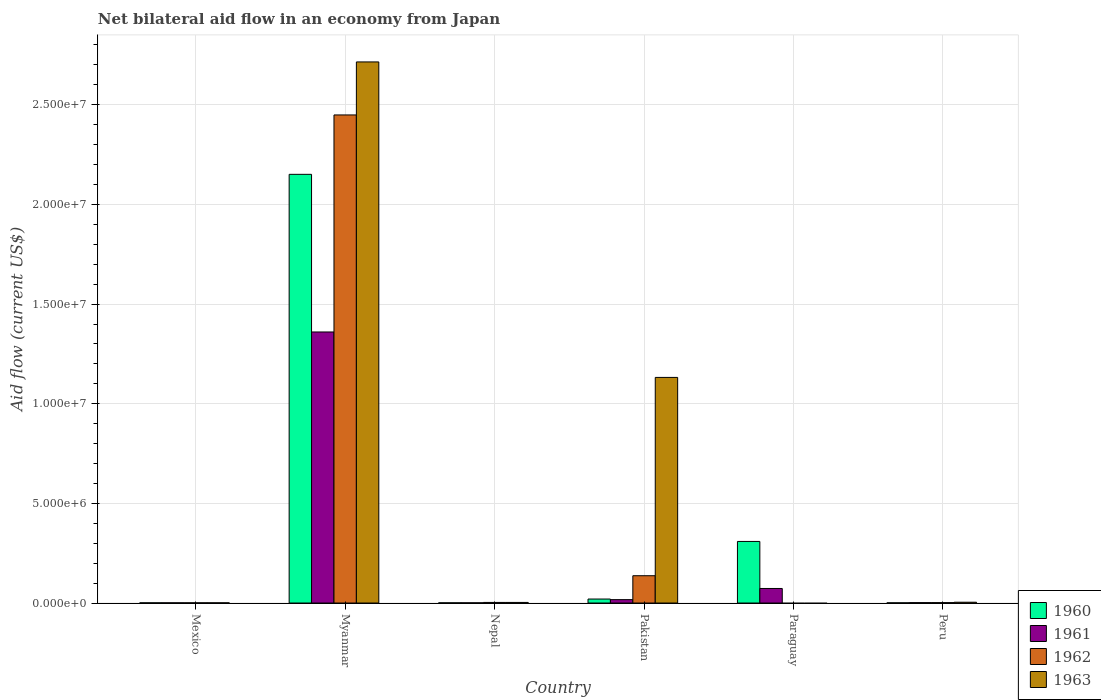How many different coloured bars are there?
Ensure brevity in your answer.  4. How many groups of bars are there?
Make the answer very short. 6. Are the number of bars per tick equal to the number of legend labels?
Make the answer very short. No. Are the number of bars on each tick of the X-axis equal?
Provide a succinct answer. No. What is the label of the 2nd group of bars from the left?
Your answer should be very brief. Myanmar. In how many cases, is the number of bars for a given country not equal to the number of legend labels?
Give a very brief answer. 1. What is the net bilateral aid flow in 1963 in Paraguay?
Your response must be concise. 0. Across all countries, what is the maximum net bilateral aid flow in 1961?
Make the answer very short. 1.36e+07. In which country was the net bilateral aid flow in 1963 maximum?
Keep it short and to the point. Myanmar. What is the total net bilateral aid flow in 1962 in the graph?
Provide a short and direct response. 2.59e+07. What is the difference between the net bilateral aid flow in 1963 in Nepal and that in Pakistan?
Offer a very short reply. -1.13e+07. What is the average net bilateral aid flow in 1961 per country?
Provide a short and direct response. 2.42e+06. What is the difference between the net bilateral aid flow of/in 1961 and net bilateral aid flow of/in 1960 in Paraguay?
Provide a short and direct response. -2.36e+06. In how many countries, is the net bilateral aid flow in 1961 greater than 20000000 US$?
Your answer should be compact. 0. What is the ratio of the net bilateral aid flow in 1962 in Mexico to that in Nepal?
Ensure brevity in your answer.  0.33. Is the net bilateral aid flow in 1962 in Myanmar less than that in Peru?
Ensure brevity in your answer.  No. What is the difference between the highest and the second highest net bilateral aid flow in 1963?
Keep it short and to the point. 2.71e+07. What is the difference between the highest and the lowest net bilateral aid flow in 1960?
Offer a very short reply. 2.15e+07. Is the sum of the net bilateral aid flow in 1962 in Mexico and Pakistan greater than the maximum net bilateral aid flow in 1963 across all countries?
Give a very brief answer. No. Are the values on the major ticks of Y-axis written in scientific E-notation?
Give a very brief answer. Yes. Does the graph contain grids?
Ensure brevity in your answer.  Yes. How many legend labels are there?
Provide a short and direct response. 4. How are the legend labels stacked?
Ensure brevity in your answer.  Vertical. What is the title of the graph?
Provide a short and direct response. Net bilateral aid flow in an economy from Japan. Does "2012" appear as one of the legend labels in the graph?
Your answer should be very brief. No. What is the label or title of the Y-axis?
Make the answer very short. Aid flow (current US$). What is the Aid flow (current US$) in 1962 in Mexico?
Offer a very short reply. 10000. What is the Aid flow (current US$) of 1963 in Mexico?
Give a very brief answer. 10000. What is the Aid flow (current US$) of 1960 in Myanmar?
Provide a short and direct response. 2.15e+07. What is the Aid flow (current US$) of 1961 in Myanmar?
Give a very brief answer. 1.36e+07. What is the Aid flow (current US$) in 1962 in Myanmar?
Offer a very short reply. 2.45e+07. What is the Aid flow (current US$) in 1963 in Myanmar?
Keep it short and to the point. 2.72e+07. What is the Aid flow (current US$) of 1961 in Nepal?
Keep it short and to the point. 10000. What is the Aid flow (current US$) of 1962 in Nepal?
Offer a very short reply. 3.00e+04. What is the Aid flow (current US$) in 1960 in Pakistan?
Your answer should be very brief. 2.00e+05. What is the Aid flow (current US$) in 1962 in Pakistan?
Provide a succinct answer. 1.37e+06. What is the Aid flow (current US$) of 1963 in Pakistan?
Your answer should be compact. 1.13e+07. What is the Aid flow (current US$) in 1960 in Paraguay?
Give a very brief answer. 3.09e+06. What is the Aid flow (current US$) in 1961 in Paraguay?
Offer a terse response. 7.30e+05. What is the Aid flow (current US$) of 1962 in Paraguay?
Ensure brevity in your answer.  0. What is the Aid flow (current US$) of 1961 in Peru?
Provide a succinct answer. 2.00e+04. Across all countries, what is the maximum Aid flow (current US$) in 1960?
Your answer should be very brief. 2.15e+07. Across all countries, what is the maximum Aid flow (current US$) of 1961?
Provide a succinct answer. 1.36e+07. Across all countries, what is the maximum Aid flow (current US$) in 1962?
Make the answer very short. 2.45e+07. Across all countries, what is the maximum Aid flow (current US$) of 1963?
Make the answer very short. 2.72e+07. Across all countries, what is the minimum Aid flow (current US$) in 1962?
Keep it short and to the point. 0. Across all countries, what is the minimum Aid flow (current US$) in 1963?
Your response must be concise. 0. What is the total Aid flow (current US$) of 1960 in the graph?
Provide a succinct answer. 2.48e+07. What is the total Aid flow (current US$) of 1961 in the graph?
Provide a short and direct response. 1.45e+07. What is the total Aid flow (current US$) in 1962 in the graph?
Ensure brevity in your answer.  2.59e+07. What is the total Aid flow (current US$) of 1963 in the graph?
Provide a succinct answer. 3.86e+07. What is the difference between the Aid flow (current US$) in 1960 in Mexico and that in Myanmar?
Offer a terse response. -2.15e+07. What is the difference between the Aid flow (current US$) of 1961 in Mexico and that in Myanmar?
Provide a short and direct response. -1.36e+07. What is the difference between the Aid flow (current US$) of 1962 in Mexico and that in Myanmar?
Your response must be concise. -2.45e+07. What is the difference between the Aid flow (current US$) of 1963 in Mexico and that in Myanmar?
Your answer should be compact. -2.71e+07. What is the difference between the Aid flow (current US$) in 1960 in Mexico and that in Nepal?
Give a very brief answer. 0. What is the difference between the Aid flow (current US$) in 1962 in Mexico and that in Nepal?
Your response must be concise. -2.00e+04. What is the difference between the Aid flow (current US$) in 1963 in Mexico and that in Nepal?
Provide a succinct answer. -2.00e+04. What is the difference between the Aid flow (current US$) of 1962 in Mexico and that in Pakistan?
Give a very brief answer. -1.36e+06. What is the difference between the Aid flow (current US$) of 1963 in Mexico and that in Pakistan?
Offer a terse response. -1.13e+07. What is the difference between the Aid flow (current US$) in 1960 in Mexico and that in Paraguay?
Keep it short and to the point. -3.08e+06. What is the difference between the Aid flow (current US$) of 1961 in Mexico and that in Paraguay?
Your answer should be compact. -7.20e+05. What is the difference between the Aid flow (current US$) of 1960 in Mexico and that in Peru?
Your answer should be very brief. 0. What is the difference between the Aid flow (current US$) of 1961 in Mexico and that in Peru?
Make the answer very short. -10000. What is the difference between the Aid flow (current US$) of 1962 in Mexico and that in Peru?
Keep it short and to the point. -10000. What is the difference between the Aid flow (current US$) in 1963 in Mexico and that in Peru?
Give a very brief answer. -3.00e+04. What is the difference between the Aid flow (current US$) of 1960 in Myanmar and that in Nepal?
Give a very brief answer. 2.15e+07. What is the difference between the Aid flow (current US$) of 1961 in Myanmar and that in Nepal?
Your answer should be compact. 1.36e+07. What is the difference between the Aid flow (current US$) of 1962 in Myanmar and that in Nepal?
Your response must be concise. 2.45e+07. What is the difference between the Aid flow (current US$) of 1963 in Myanmar and that in Nepal?
Keep it short and to the point. 2.71e+07. What is the difference between the Aid flow (current US$) in 1960 in Myanmar and that in Pakistan?
Provide a short and direct response. 2.13e+07. What is the difference between the Aid flow (current US$) in 1961 in Myanmar and that in Pakistan?
Your answer should be very brief. 1.34e+07. What is the difference between the Aid flow (current US$) in 1962 in Myanmar and that in Pakistan?
Make the answer very short. 2.31e+07. What is the difference between the Aid flow (current US$) of 1963 in Myanmar and that in Pakistan?
Provide a short and direct response. 1.58e+07. What is the difference between the Aid flow (current US$) in 1960 in Myanmar and that in Paraguay?
Give a very brief answer. 1.84e+07. What is the difference between the Aid flow (current US$) in 1961 in Myanmar and that in Paraguay?
Give a very brief answer. 1.29e+07. What is the difference between the Aid flow (current US$) in 1960 in Myanmar and that in Peru?
Offer a very short reply. 2.15e+07. What is the difference between the Aid flow (current US$) in 1961 in Myanmar and that in Peru?
Keep it short and to the point. 1.36e+07. What is the difference between the Aid flow (current US$) of 1962 in Myanmar and that in Peru?
Give a very brief answer. 2.45e+07. What is the difference between the Aid flow (current US$) of 1963 in Myanmar and that in Peru?
Provide a short and direct response. 2.71e+07. What is the difference between the Aid flow (current US$) in 1961 in Nepal and that in Pakistan?
Offer a very short reply. -1.60e+05. What is the difference between the Aid flow (current US$) in 1962 in Nepal and that in Pakistan?
Provide a succinct answer. -1.34e+06. What is the difference between the Aid flow (current US$) of 1963 in Nepal and that in Pakistan?
Keep it short and to the point. -1.13e+07. What is the difference between the Aid flow (current US$) in 1960 in Nepal and that in Paraguay?
Your answer should be very brief. -3.08e+06. What is the difference between the Aid flow (current US$) of 1961 in Nepal and that in Paraguay?
Provide a succinct answer. -7.20e+05. What is the difference between the Aid flow (current US$) of 1962 in Nepal and that in Peru?
Give a very brief answer. 10000. What is the difference between the Aid flow (current US$) of 1960 in Pakistan and that in Paraguay?
Give a very brief answer. -2.89e+06. What is the difference between the Aid flow (current US$) in 1961 in Pakistan and that in Paraguay?
Ensure brevity in your answer.  -5.60e+05. What is the difference between the Aid flow (current US$) in 1960 in Pakistan and that in Peru?
Offer a terse response. 1.90e+05. What is the difference between the Aid flow (current US$) of 1962 in Pakistan and that in Peru?
Provide a short and direct response. 1.35e+06. What is the difference between the Aid flow (current US$) in 1963 in Pakistan and that in Peru?
Make the answer very short. 1.13e+07. What is the difference between the Aid flow (current US$) in 1960 in Paraguay and that in Peru?
Your response must be concise. 3.08e+06. What is the difference between the Aid flow (current US$) in 1961 in Paraguay and that in Peru?
Your answer should be very brief. 7.10e+05. What is the difference between the Aid flow (current US$) of 1960 in Mexico and the Aid flow (current US$) of 1961 in Myanmar?
Offer a terse response. -1.36e+07. What is the difference between the Aid flow (current US$) of 1960 in Mexico and the Aid flow (current US$) of 1962 in Myanmar?
Ensure brevity in your answer.  -2.45e+07. What is the difference between the Aid flow (current US$) of 1960 in Mexico and the Aid flow (current US$) of 1963 in Myanmar?
Offer a very short reply. -2.71e+07. What is the difference between the Aid flow (current US$) in 1961 in Mexico and the Aid flow (current US$) in 1962 in Myanmar?
Provide a short and direct response. -2.45e+07. What is the difference between the Aid flow (current US$) in 1961 in Mexico and the Aid flow (current US$) in 1963 in Myanmar?
Keep it short and to the point. -2.71e+07. What is the difference between the Aid flow (current US$) in 1962 in Mexico and the Aid flow (current US$) in 1963 in Myanmar?
Give a very brief answer. -2.71e+07. What is the difference between the Aid flow (current US$) in 1960 in Mexico and the Aid flow (current US$) in 1962 in Nepal?
Make the answer very short. -2.00e+04. What is the difference between the Aid flow (current US$) of 1962 in Mexico and the Aid flow (current US$) of 1963 in Nepal?
Keep it short and to the point. -2.00e+04. What is the difference between the Aid flow (current US$) of 1960 in Mexico and the Aid flow (current US$) of 1961 in Pakistan?
Provide a succinct answer. -1.60e+05. What is the difference between the Aid flow (current US$) in 1960 in Mexico and the Aid flow (current US$) in 1962 in Pakistan?
Give a very brief answer. -1.36e+06. What is the difference between the Aid flow (current US$) of 1960 in Mexico and the Aid flow (current US$) of 1963 in Pakistan?
Offer a very short reply. -1.13e+07. What is the difference between the Aid flow (current US$) in 1961 in Mexico and the Aid flow (current US$) in 1962 in Pakistan?
Offer a terse response. -1.36e+06. What is the difference between the Aid flow (current US$) of 1961 in Mexico and the Aid flow (current US$) of 1963 in Pakistan?
Your answer should be compact. -1.13e+07. What is the difference between the Aid flow (current US$) of 1962 in Mexico and the Aid flow (current US$) of 1963 in Pakistan?
Your answer should be very brief. -1.13e+07. What is the difference between the Aid flow (current US$) of 1960 in Mexico and the Aid flow (current US$) of 1961 in Paraguay?
Offer a very short reply. -7.20e+05. What is the difference between the Aid flow (current US$) of 1960 in Mexico and the Aid flow (current US$) of 1961 in Peru?
Provide a short and direct response. -10000. What is the difference between the Aid flow (current US$) of 1961 in Mexico and the Aid flow (current US$) of 1963 in Peru?
Your answer should be very brief. -3.00e+04. What is the difference between the Aid flow (current US$) in 1960 in Myanmar and the Aid flow (current US$) in 1961 in Nepal?
Your response must be concise. 2.15e+07. What is the difference between the Aid flow (current US$) in 1960 in Myanmar and the Aid flow (current US$) in 1962 in Nepal?
Your answer should be very brief. 2.15e+07. What is the difference between the Aid flow (current US$) of 1960 in Myanmar and the Aid flow (current US$) of 1963 in Nepal?
Provide a succinct answer. 2.15e+07. What is the difference between the Aid flow (current US$) of 1961 in Myanmar and the Aid flow (current US$) of 1962 in Nepal?
Make the answer very short. 1.36e+07. What is the difference between the Aid flow (current US$) of 1961 in Myanmar and the Aid flow (current US$) of 1963 in Nepal?
Offer a very short reply. 1.36e+07. What is the difference between the Aid flow (current US$) of 1962 in Myanmar and the Aid flow (current US$) of 1963 in Nepal?
Give a very brief answer. 2.45e+07. What is the difference between the Aid flow (current US$) of 1960 in Myanmar and the Aid flow (current US$) of 1961 in Pakistan?
Your answer should be very brief. 2.13e+07. What is the difference between the Aid flow (current US$) of 1960 in Myanmar and the Aid flow (current US$) of 1962 in Pakistan?
Provide a succinct answer. 2.01e+07. What is the difference between the Aid flow (current US$) of 1960 in Myanmar and the Aid flow (current US$) of 1963 in Pakistan?
Keep it short and to the point. 1.02e+07. What is the difference between the Aid flow (current US$) of 1961 in Myanmar and the Aid flow (current US$) of 1962 in Pakistan?
Give a very brief answer. 1.22e+07. What is the difference between the Aid flow (current US$) of 1961 in Myanmar and the Aid flow (current US$) of 1963 in Pakistan?
Make the answer very short. 2.28e+06. What is the difference between the Aid flow (current US$) of 1962 in Myanmar and the Aid flow (current US$) of 1963 in Pakistan?
Your answer should be very brief. 1.32e+07. What is the difference between the Aid flow (current US$) of 1960 in Myanmar and the Aid flow (current US$) of 1961 in Paraguay?
Offer a very short reply. 2.08e+07. What is the difference between the Aid flow (current US$) in 1960 in Myanmar and the Aid flow (current US$) in 1961 in Peru?
Offer a terse response. 2.15e+07. What is the difference between the Aid flow (current US$) of 1960 in Myanmar and the Aid flow (current US$) of 1962 in Peru?
Offer a terse response. 2.15e+07. What is the difference between the Aid flow (current US$) of 1960 in Myanmar and the Aid flow (current US$) of 1963 in Peru?
Provide a short and direct response. 2.15e+07. What is the difference between the Aid flow (current US$) of 1961 in Myanmar and the Aid flow (current US$) of 1962 in Peru?
Offer a terse response. 1.36e+07. What is the difference between the Aid flow (current US$) of 1961 in Myanmar and the Aid flow (current US$) of 1963 in Peru?
Offer a terse response. 1.36e+07. What is the difference between the Aid flow (current US$) in 1962 in Myanmar and the Aid flow (current US$) in 1963 in Peru?
Your answer should be very brief. 2.44e+07. What is the difference between the Aid flow (current US$) of 1960 in Nepal and the Aid flow (current US$) of 1962 in Pakistan?
Make the answer very short. -1.36e+06. What is the difference between the Aid flow (current US$) in 1960 in Nepal and the Aid flow (current US$) in 1963 in Pakistan?
Provide a short and direct response. -1.13e+07. What is the difference between the Aid flow (current US$) of 1961 in Nepal and the Aid flow (current US$) of 1962 in Pakistan?
Your answer should be very brief. -1.36e+06. What is the difference between the Aid flow (current US$) of 1961 in Nepal and the Aid flow (current US$) of 1963 in Pakistan?
Give a very brief answer. -1.13e+07. What is the difference between the Aid flow (current US$) in 1962 in Nepal and the Aid flow (current US$) in 1963 in Pakistan?
Offer a terse response. -1.13e+07. What is the difference between the Aid flow (current US$) of 1960 in Nepal and the Aid flow (current US$) of 1961 in Paraguay?
Your answer should be very brief. -7.20e+05. What is the difference between the Aid flow (current US$) of 1960 in Nepal and the Aid flow (current US$) of 1961 in Peru?
Provide a short and direct response. -10000. What is the difference between the Aid flow (current US$) in 1960 in Nepal and the Aid flow (current US$) in 1963 in Peru?
Your response must be concise. -3.00e+04. What is the difference between the Aid flow (current US$) of 1961 in Nepal and the Aid flow (current US$) of 1962 in Peru?
Give a very brief answer. -10000. What is the difference between the Aid flow (current US$) in 1961 in Nepal and the Aid flow (current US$) in 1963 in Peru?
Provide a short and direct response. -3.00e+04. What is the difference between the Aid flow (current US$) of 1960 in Pakistan and the Aid flow (current US$) of 1961 in Paraguay?
Provide a succinct answer. -5.30e+05. What is the difference between the Aid flow (current US$) of 1960 in Pakistan and the Aid flow (current US$) of 1962 in Peru?
Your response must be concise. 1.80e+05. What is the difference between the Aid flow (current US$) of 1961 in Pakistan and the Aid flow (current US$) of 1962 in Peru?
Your answer should be very brief. 1.50e+05. What is the difference between the Aid flow (current US$) in 1962 in Pakistan and the Aid flow (current US$) in 1963 in Peru?
Make the answer very short. 1.33e+06. What is the difference between the Aid flow (current US$) in 1960 in Paraguay and the Aid flow (current US$) in 1961 in Peru?
Your answer should be very brief. 3.07e+06. What is the difference between the Aid flow (current US$) of 1960 in Paraguay and the Aid flow (current US$) of 1962 in Peru?
Give a very brief answer. 3.07e+06. What is the difference between the Aid flow (current US$) in 1960 in Paraguay and the Aid flow (current US$) in 1963 in Peru?
Your answer should be compact. 3.05e+06. What is the difference between the Aid flow (current US$) in 1961 in Paraguay and the Aid flow (current US$) in 1962 in Peru?
Your response must be concise. 7.10e+05. What is the difference between the Aid flow (current US$) in 1961 in Paraguay and the Aid flow (current US$) in 1963 in Peru?
Provide a short and direct response. 6.90e+05. What is the average Aid flow (current US$) of 1960 per country?
Your answer should be very brief. 4.14e+06. What is the average Aid flow (current US$) of 1961 per country?
Offer a very short reply. 2.42e+06. What is the average Aid flow (current US$) of 1962 per country?
Keep it short and to the point. 4.32e+06. What is the average Aid flow (current US$) in 1963 per country?
Ensure brevity in your answer.  6.42e+06. What is the difference between the Aid flow (current US$) in 1960 and Aid flow (current US$) in 1961 in Mexico?
Your response must be concise. 0. What is the difference between the Aid flow (current US$) of 1960 and Aid flow (current US$) of 1962 in Mexico?
Give a very brief answer. 0. What is the difference between the Aid flow (current US$) in 1962 and Aid flow (current US$) in 1963 in Mexico?
Your answer should be compact. 0. What is the difference between the Aid flow (current US$) in 1960 and Aid flow (current US$) in 1961 in Myanmar?
Offer a terse response. 7.91e+06. What is the difference between the Aid flow (current US$) of 1960 and Aid flow (current US$) of 1962 in Myanmar?
Provide a succinct answer. -2.98e+06. What is the difference between the Aid flow (current US$) in 1960 and Aid flow (current US$) in 1963 in Myanmar?
Keep it short and to the point. -5.64e+06. What is the difference between the Aid flow (current US$) in 1961 and Aid flow (current US$) in 1962 in Myanmar?
Offer a terse response. -1.09e+07. What is the difference between the Aid flow (current US$) in 1961 and Aid flow (current US$) in 1963 in Myanmar?
Your answer should be compact. -1.36e+07. What is the difference between the Aid flow (current US$) of 1962 and Aid flow (current US$) of 1963 in Myanmar?
Offer a very short reply. -2.66e+06. What is the difference between the Aid flow (current US$) of 1961 and Aid flow (current US$) of 1963 in Nepal?
Provide a short and direct response. -2.00e+04. What is the difference between the Aid flow (current US$) in 1962 and Aid flow (current US$) in 1963 in Nepal?
Your response must be concise. 0. What is the difference between the Aid flow (current US$) in 1960 and Aid flow (current US$) in 1962 in Pakistan?
Give a very brief answer. -1.17e+06. What is the difference between the Aid flow (current US$) in 1960 and Aid flow (current US$) in 1963 in Pakistan?
Provide a succinct answer. -1.11e+07. What is the difference between the Aid flow (current US$) of 1961 and Aid flow (current US$) of 1962 in Pakistan?
Offer a terse response. -1.20e+06. What is the difference between the Aid flow (current US$) of 1961 and Aid flow (current US$) of 1963 in Pakistan?
Keep it short and to the point. -1.12e+07. What is the difference between the Aid flow (current US$) of 1962 and Aid flow (current US$) of 1963 in Pakistan?
Your answer should be very brief. -9.95e+06. What is the difference between the Aid flow (current US$) in 1960 and Aid flow (current US$) in 1961 in Paraguay?
Your answer should be very brief. 2.36e+06. What is the difference between the Aid flow (current US$) of 1961 and Aid flow (current US$) of 1963 in Peru?
Offer a terse response. -2.00e+04. What is the ratio of the Aid flow (current US$) in 1960 in Mexico to that in Myanmar?
Provide a short and direct response. 0. What is the ratio of the Aid flow (current US$) in 1961 in Mexico to that in Myanmar?
Give a very brief answer. 0. What is the ratio of the Aid flow (current US$) of 1963 in Mexico to that in Myanmar?
Offer a terse response. 0. What is the ratio of the Aid flow (current US$) of 1961 in Mexico to that in Nepal?
Your answer should be compact. 1. What is the ratio of the Aid flow (current US$) in 1960 in Mexico to that in Pakistan?
Provide a short and direct response. 0.05. What is the ratio of the Aid flow (current US$) of 1961 in Mexico to that in Pakistan?
Give a very brief answer. 0.06. What is the ratio of the Aid flow (current US$) in 1962 in Mexico to that in Pakistan?
Your answer should be very brief. 0.01. What is the ratio of the Aid flow (current US$) in 1963 in Mexico to that in Pakistan?
Keep it short and to the point. 0. What is the ratio of the Aid flow (current US$) in 1960 in Mexico to that in Paraguay?
Make the answer very short. 0. What is the ratio of the Aid flow (current US$) of 1961 in Mexico to that in Paraguay?
Offer a very short reply. 0.01. What is the ratio of the Aid flow (current US$) in 1962 in Mexico to that in Peru?
Give a very brief answer. 0.5. What is the ratio of the Aid flow (current US$) of 1960 in Myanmar to that in Nepal?
Give a very brief answer. 2151. What is the ratio of the Aid flow (current US$) of 1961 in Myanmar to that in Nepal?
Keep it short and to the point. 1360. What is the ratio of the Aid flow (current US$) in 1962 in Myanmar to that in Nepal?
Your response must be concise. 816.33. What is the ratio of the Aid flow (current US$) in 1963 in Myanmar to that in Nepal?
Offer a terse response. 905. What is the ratio of the Aid flow (current US$) of 1960 in Myanmar to that in Pakistan?
Give a very brief answer. 107.55. What is the ratio of the Aid flow (current US$) in 1962 in Myanmar to that in Pakistan?
Keep it short and to the point. 17.88. What is the ratio of the Aid flow (current US$) of 1963 in Myanmar to that in Pakistan?
Offer a very short reply. 2.4. What is the ratio of the Aid flow (current US$) of 1960 in Myanmar to that in Paraguay?
Give a very brief answer. 6.96. What is the ratio of the Aid flow (current US$) of 1961 in Myanmar to that in Paraguay?
Offer a very short reply. 18.63. What is the ratio of the Aid flow (current US$) in 1960 in Myanmar to that in Peru?
Your answer should be compact. 2151. What is the ratio of the Aid flow (current US$) of 1961 in Myanmar to that in Peru?
Provide a succinct answer. 680. What is the ratio of the Aid flow (current US$) of 1962 in Myanmar to that in Peru?
Ensure brevity in your answer.  1224.5. What is the ratio of the Aid flow (current US$) of 1963 in Myanmar to that in Peru?
Ensure brevity in your answer.  678.75. What is the ratio of the Aid flow (current US$) of 1961 in Nepal to that in Pakistan?
Your answer should be very brief. 0.06. What is the ratio of the Aid flow (current US$) in 1962 in Nepal to that in Pakistan?
Make the answer very short. 0.02. What is the ratio of the Aid flow (current US$) of 1963 in Nepal to that in Pakistan?
Keep it short and to the point. 0. What is the ratio of the Aid flow (current US$) in 1960 in Nepal to that in Paraguay?
Give a very brief answer. 0. What is the ratio of the Aid flow (current US$) of 1961 in Nepal to that in Paraguay?
Offer a terse response. 0.01. What is the ratio of the Aid flow (current US$) of 1960 in Nepal to that in Peru?
Offer a very short reply. 1. What is the ratio of the Aid flow (current US$) in 1961 in Nepal to that in Peru?
Provide a succinct answer. 0.5. What is the ratio of the Aid flow (current US$) of 1962 in Nepal to that in Peru?
Your answer should be compact. 1.5. What is the ratio of the Aid flow (current US$) in 1963 in Nepal to that in Peru?
Your response must be concise. 0.75. What is the ratio of the Aid flow (current US$) in 1960 in Pakistan to that in Paraguay?
Your response must be concise. 0.06. What is the ratio of the Aid flow (current US$) in 1961 in Pakistan to that in Paraguay?
Give a very brief answer. 0.23. What is the ratio of the Aid flow (current US$) in 1962 in Pakistan to that in Peru?
Ensure brevity in your answer.  68.5. What is the ratio of the Aid flow (current US$) in 1963 in Pakistan to that in Peru?
Your response must be concise. 283. What is the ratio of the Aid flow (current US$) of 1960 in Paraguay to that in Peru?
Your response must be concise. 309. What is the ratio of the Aid flow (current US$) of 1961 in Paraguay to that in Peru?
Your response must be concise. 36.5. What is the difference between the highest and the second highest Aid flow (current US$) of 1960?
Keep it short and to the point. 1.84e+07. What is the difference between the highest and the second highest Aid flow (current US$) in 1961?
Keep it short and to the point. 1.29e+07. What is the difference between the highest and the second highest Aid flow (current US$) in 1962?
Make the answer very short. 2.31e+07. What is the difference between the highest and the second highest Aid flow (current US$) in 1963?
Your response must be concise. 1.58e+07. What is the difference between the highest and the lowest Aid flow (current US$) of 1960?
Give a very brief answer. 2.15e+07. What is the difference between the highest and the lowest Aid flow (current US$) of 1961?
Offer a very short reply. 1.36e+07. What is the difference between the highest and the lowest Aid flow (current US$) of 1962?
Make the answer very short. 2.45e+07. What is the difference between the highest and the lowest Aid flow (current US$) in 1963?
Ensure brevity in your answer.  2.72e+07. 